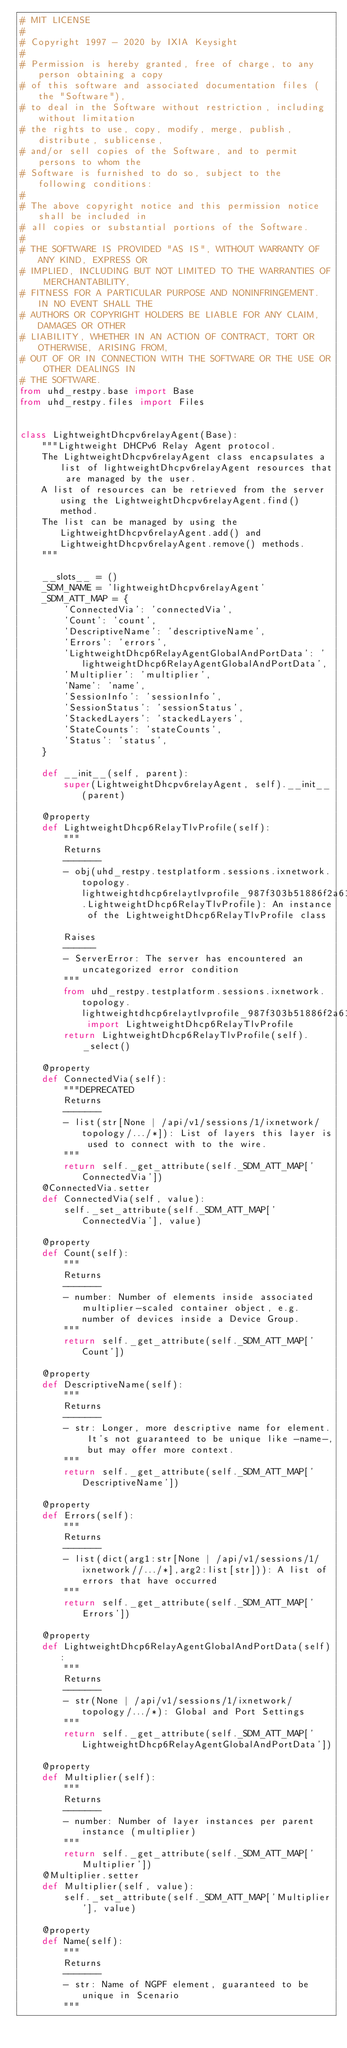Convert code to text. <code><loc_0><loc_0><loc_500><loc_500><_Python_># MIT LICENSE
#
# Copyright 1997 - 2020 by IXIA Keysight
#
# Permission is hereby granted, free of charge, to any person obtaining a copy
# of this software and associated documentation files (the "Software"),
# to deal in the Software without restriction, including without limitation
# the rights to use, copy, modify, merge, publish, distribute, sublicense,
# and/or sell copies of the Software, and to permit persons to whom the
# Software is furnished to do so, subject to the following conditions:
#
# The above copyright notice and this permission notice shall be included in
# all copies or substantial portions of the Software.
#
# THE SOFTWARE IS PROVIDED "AS IS", WITHOUT WARRANTY OF ANY KIND, EXPRESS OR
# IMPLIED, INCLUDING BUT NOT LIMITED TO THE WARRANTIES OF MERCHANTABILITY,
# FITNESS FOR A PARTICULAR PURPOSE AND NONINFRINGEMENT. IN NO EVENT SHALL THE
# AUTHORS OR COPYRIGHT HOLDERS BE LIABLE FOR ANY CLAIM, DAMAGES OR OTHER
# LIABILITY, WHETHER IN AN ACTION OF CONTRACT, TORT OR OTHERWISE, ARISING FROM,
# OUT OF OR IN CONNECTION WITH THE SOFTWARE OR THE USE OR OTHER DEALINGS IN
# THE SOFTWARE. 
from uhd_restpy.base import Base
from uhd_restpy.files import Files


class LightweightDhcpv6relayAgent(Base):
    """Lightweight DHCPv6 Relay Agent protocol.
    The LightweightDhcpv6relayAgent class encapsulates a list of lightweightDhcpv6relayAgent resources that are managed by the user.
    A list of resources can be retrieved from the server using the LightweightDhcpv6relayAgent.find() method.
    The list can be managed by using the LightweightDhcpv6relayAgent.add() and LightweightDhcpv6relayAgent.remove() methods.
    """

    __slots__ = ()
    _SDM_NAME = 'lightweightDhcpv6relayAgent'
    _SDM_ATT_MAP = {
        'ConnectedVia': 'connectedVia',
        'Count': 'count',
        'DescriptiveName': 'descriptiveName',
        'Errors': 'errors',
        'LightweightDhcp6RelayAgentGlobalAndPortData': 'lightweightDhcp6RelayAgentGlobalAndPortData',
        'Multiplier': 'multiplier',
        'Name': 'name',
        'SessionInfo': 'sessionInfo',
        'SessionStatus': 'sessionStatus',
        'StackedLayers': 'stackedLayers',
        'StateCounts': 'stateCounts',
        'Status': 'status',
    }

    def __init__(self, parent):
        super(LightweightDhcpv6relayAgent, self).__init__(parent)

    @property
    def LightweightDhcp6RelayTlvProfile(self):
        """
        Returns
        -------
        - obj(uhd_restpy.testplatform.sessions.ixnetwork.topology.lightweightdhcp6relaytlvprofile_987f303b51886f2a61c9c1388518f037.LightweightDhcp6RelayTlvProfile): An instance of the LightweightDhcp6RelayTlvProfile class

        Raises
        ------
        - ServerError: The server has encountered an uncategorized error condition
        """
        from uhd_restpy.testplatform.sessions.ixnetwork.topology.lightweightdhcp6relaytlvprofile_987f303b51886f2a61c9c1388518f037 import LightweightDhcp6RelayTlvProfile
        return LightweightDhcp6RelayTlvProfile(self)._select()

    @property
    def ConnectedVia(self):
        """DEPRECATED 
        Returns
        -------
        - list(str[None | /api/v1/sessions/1/ixnetwork/topology/.../*]): List of layers this layer is used to connect with to the wire.
        """
        return self._get_attribute(self._SDM_ATT_MAP['ConnectedVia'])
    @ConnectedVia.setter
    def ConnectedVia(self, value):
        self._set_attribute(self._SDM_ATT_MAP['ConnectedVia'], value)

    @property
    def Count(self):
        """
        Returns
        -------
        - number: Number of elements inside associated multiplier-scaled container object, e.g. number of devices inside a Device Group.
        """
        return self._get_attribute(self._SDM_ATT_MAP['Count'])

    @property
    def DescriptiveName(self):
        """
        Returns
        -------
        - str: Longer, more descriptive name for element. It's not guaranteed to be unique like -name-, but may offer more context.
        """
        return self._get_attribute(self._SDM_ATT_MAP['DescriptiveName'])

    @property
    def Errors(self):
        """
        Returns
        -------
        - list(dict(arg1:str[None | /api/v1/sessions/1/ixnetwork//.../*],arg2:list[str])): A list of errors that have occurred
        """
        return self._get_attribute(self._SDM_ATT_MAP['Errors'])

    @property
    def LightweightDhcp6RelayAgentGlobalAndPortData(self):
        """
        Returns
        -------
        - str(None | /api/v1/sessions/1/ixnetwork/topology/.../*): Global and Port Settings
        """
        return self._get_attribute(self._SDM_ATT_MAP['LightweightDhcp6RelayAgentGlobalAndPortData'])

    @property
    def Multiplier(self):
        """
        Returns
        -------
        - number: Number of layer instances per parent instance (multiplier)
        """
        return self._get_attribute(self._SDM_ATT_MAP['Multiplier'])
    @Multiplier.setter
    def Multiplier(self, value):
        self._set_attribute(self._SDM_ATT_MAP['Multiplier'], value)

    @property
    def Name(self):
        """
        Returns
        -------
        - str: Name of NGPF element, guaranteed to be unique in Scenario
        """</code> 